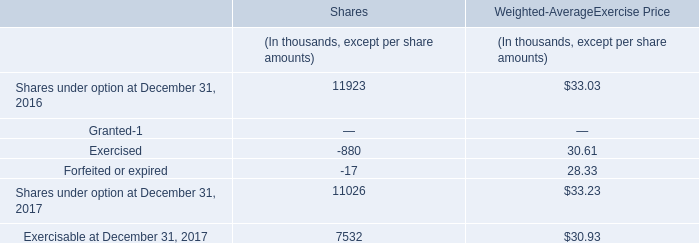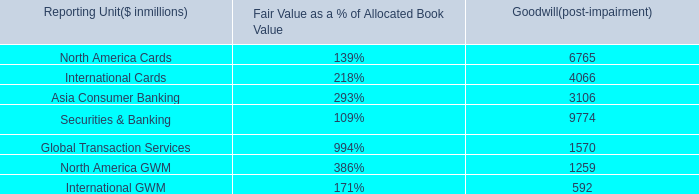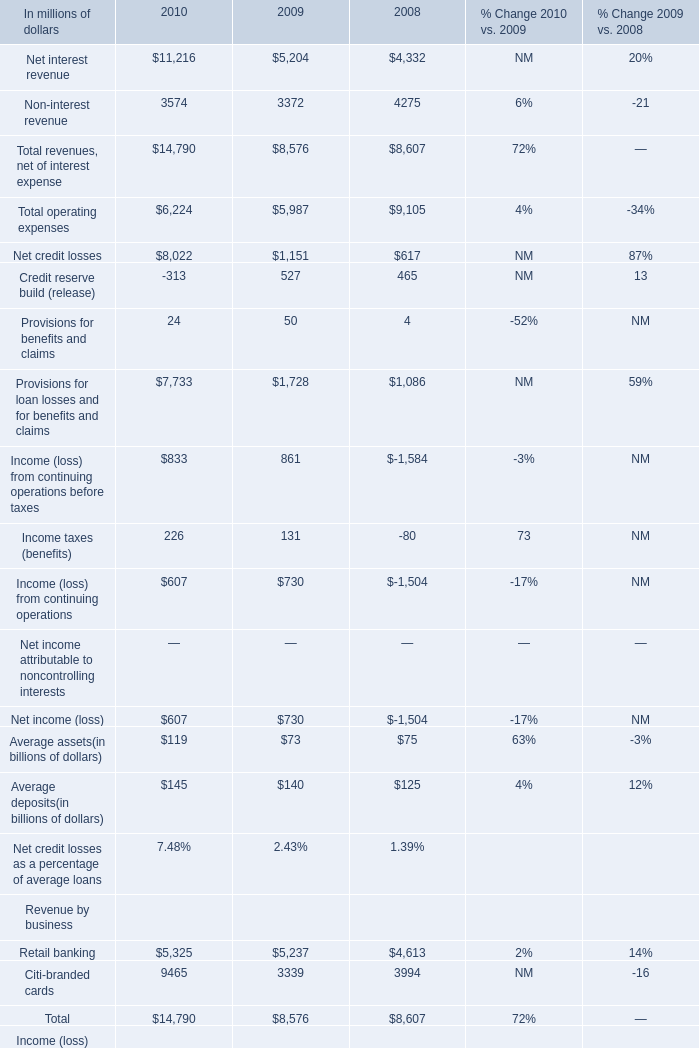How many revenues, net of interest expenses keep increasing each year between 2008 and 2010? 
Answer: 1. 